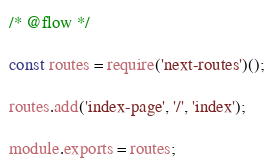<code> <loc_0><loc_0><loc_500><loc_500><_JavaScript_>/* @flow */

const routes = require('next-routes')();

routes.add('index-page', '/', 'index');

module.exports = routes;
</code> 